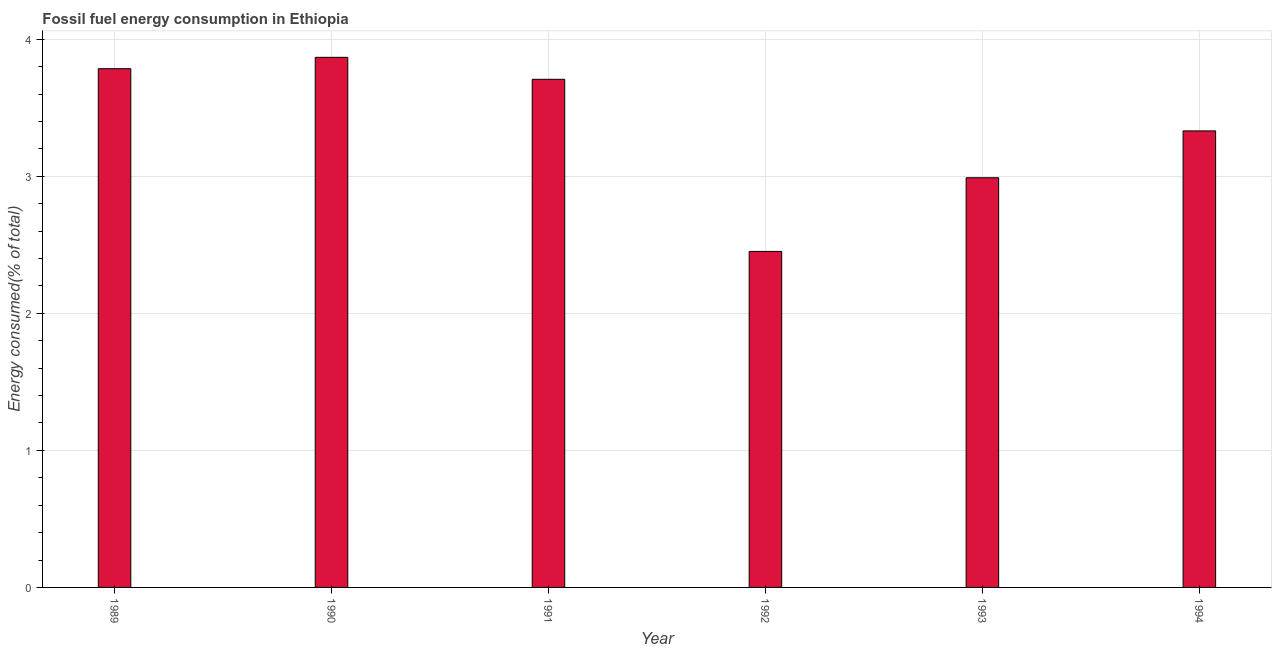Does the graph contain any zero values?
Your answer should be very brief. No. Does the graph contain grids?
Give a very brief answer. Yes. What is the title of the graph?
Provide a short and direct response. Fossil fuel energy consumption in Ethiopia. What is the label or title of the X-axis?
Your answer should be very brief. Year. What is the label or title of the Y-axis?
Provide a succinct answer. Energy consumed(% of total). What is the fossil fuel energy consumption in 1994?
Make the answer very short. 3.33. Across all years, what is the maximum fossil fuel energy consumption?
Provide a succinct answer. 3.87. Across all years, what is the minimum fossil fuel energy consumption?
Your answer should be compact. 2.45. In which year was the fossil fuel energy consumption maximum?
Provide a succinct answer. 1990. In which year was the fossil fuel energy consumption minimum?
Provide a succinct answer. 1992. What is the sum of the fossil fuel energy consumption?
Offer a terse response. 20.14. What is the difference between the fossil fuel energy consumption in 1991 and 1994?
Provide a short and direct response. 0.38. What is the average fossil fuel energy consumption per year?
Your answer should be compact. 3.36. What is the median fossil fuel energy consumption?
Keep it short and to the point. 3.52. In how many years, is the fossil fuel energy consumption greater than 2.4 %?
Your answer should be compact. 6. Do a majority of the years between 1990 and 1989 (inclusive) have fossil fuel energy consumption greater than 0.6 %?
Your response must be concise. No. What is the ratio of the fossil fuel energy consumption in 1990 to that in 1993?
Give a very brief answer. 1.29. What is the difference between the highest and the second highest fossil fuel energy consumption?
Offer a terse response. 0.08. What is the difference between the highest and the lowest fossil fuel energy consumption?
Ensure brevity in your answer.  1.42. How many bars are there?
Offer a terse response. 6. How many years are there in the graph?
Your answer should be very brief. 6. What is the Energy consumed(% of total) in 1989?
Make the answer very short. 3.79. What is the Energy consumed(% of total) of 1990?
Provide a succinct answer. 3.87. What is the Energy consumed(% of total) in 1991?
Offer a very short reply. 3.71. What is the Energy consumed(% of total) of 1992?
Provide a succinct answer. 2.45. What is the Energy consumed(% of total) in 1993?
Make the answer very short. 2.99. What is the Energy consumed(% of total) in 1994?
Offer a very short reply. 3.33. What is the difference between the Energy consumed(% of total) in 1989 and 1990?
Give a very brief answer. -0.08. What is the difference between the Energy consumed(% of total) in 1989 and 1991?
Offer a very short reply. 0.08. What is the difference between the Energy consumed(% of total) in 1989 and 1992?
Ensure brevity in your answer.  1.33. What is the difference between the Energy consumed(% of total) in 1989 and 1993?
Provide a short and direct response. 0.8. What is the difference between the Energy consumed(% of total) in 1989 and 1994?
Provide a short and direct response. 0.45. What is the difference between the Energy consumed(% of total) in 1990 and 1991?
Give a very brief answer. 0.16. What is the difference between the Energy consumed(% of total) in 1990 and 1992?
Your answer should be compact. 1.42. What is the difference between the Energy consumed(% of total) in 1990 and 1993?
Your response must be concise. 0.88. What is the difference between the Energy consumed(% of total) in 1990 and 1994?
Provide a short and direct response. 0.54. What is the difference between the Energy consumed(% of total) in 1991 and 1992?
Give a very brief answer. 1.26. What is the difference between the Energy consumed(% of total) in 1991 and 1993?
Your answer should be very brief. 0.72. What is the difference between the Energy consumed(% of total) in 1991 and 1994?
Provide a succinct answer. 0.38. What is the difference between the Energy consumed(% of total) in 1992 and 1993?
Provide a succinct answer. -0.54. What is the difference between the Energy consumed(% of total) in 1992 and 1994?
Offer a very short reply. -0.88. What is the difference between the Energy consumed(% of total) in 1993 and 1994?
Your answer should be very brief. -0.34. What is the ratio of the Energy consumed(% of total) in 1989 to that in 1990?
Your answer should be very brief. 0.98. What is the ratio of the Energy consumed(% of total) in 1989 to that in 1992?
Offer a terse response. 1.54. What is the ratio of the Energy consumed(% of total) in 1989 to that in 1993?
Your response must be concise. 1.27. What is the ratio of the Energy consumed(% of total) in 1989 to that in 1994?
Your answer should be compact. 1.14. What is the ratio of the Energy consumed(% of total) in 1990 to that in 1991?
Give a very brief answer. 1.04. What is the ratio of the Energy consumed(% of total) in 1990 to that in 1992?
Keep it short and to the point. 1.58. What is the ratio of the Energy consumed(% of total) in 1990 to that in 1993?
Give a very brief answer. 1.29. What is the ratio of the Energy consumed(% of total) in 1990 to that in 1994?
Give a very brief answer. 1.16. What is the ratio of the Energy consumed(% of total) in 1991 to that in 1992?
Offer a very short reply. 1.51. What is the ratio of the Energy consumed(% of total) in 1991 to that in 1993?
Your response must be concise. 1.24. What is the ratio of the Energy consumed(% of total) in 1991 to that in 1994?
Provide a succinct answer. 1.11. What is the ratio of the Energy consumed(% of total) in 1992 to that in 1993?
Ensure brevity in your answer.  0.82. What is the ratio of the Energy consumed(% of total) in 1992 to that in 1994?
Provide a short and direct response. 0.74. What is the ratio of the Energy consumed(% of total) in 1993 to that in 1994?
Offer a very short reply. 0.9. 